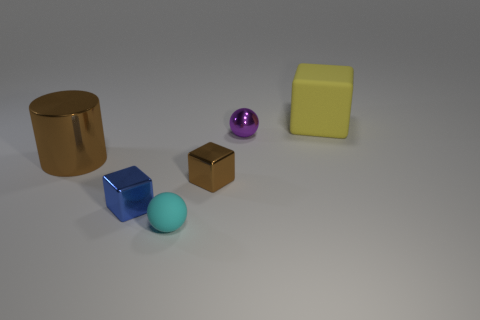Subtract all shiny blocks. How many blocks are left? 1 Add 3 big red things. How many objects exist? 9 Subtract all blue blocks. How many blocks are left? 2 Subtract all cylinders. How many objects are left? 5 Subtract 0 green cylinders. How many objects are left? 6 Subtract 1 cylinders. How many cylinders are left? 0 Subtract all yellow cylinders. Subtract all purple blocks. How many cylinders are left? 1 Subtract all green balls. How many yellow cylinders are left? 0 Subtract all small brown objects. Subtract all large cylinders. How many objects are left? 4 Add 2 metal blocks. How many metal blocks are left? 4 